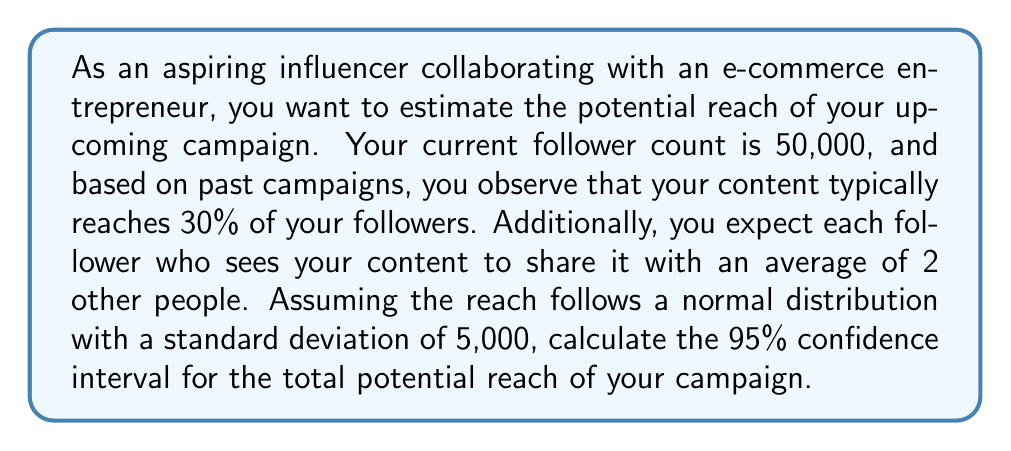Teach me how to tackle this problem. Let's approach this problem step-by-step:

1. Calculate the expected direct reach:
   $$ \text{Direct Reach} = 50,000 \times 0.30 = 15,000 \text{ followers} $$

2. Calculate the expected indirect reach:
   $$ \text{Indirect Reach} = 15,000 \times 2 = 30,000 \text{ people} $$

3. Calculate the total expected reach:
   $$ \text{Total Expected Reach} = 15,000 + 30,000 = 45,000 \text{ people} $$

4. For a 95% confidence interval, we need to find the z-score, which is 1.96 for a two-tailed test.

5. The formula for the confidence interval is:
   $$ CI = \bar{x} \pm z \frac{\sigma}{\sqrt{n}} $$
   Where:
   - $\bar{x}$ is the expected reach (45,000)
   - $z$ is the z-score (1.96)
   - $\sigma$ is the standard deviation (5,000)
   - $n$ is the sample size, which in this case is 1 as we're dealing with a single campaign

6. Plugging in the values:
   $$ CI = 45,000 \pm 1.96 \frac{5,000}{\sqrt{1}} $$
   $$ CI = 45,000 \pm 1.96 \times 5,000 $$
   $$ CI = 45,000 \pm 9,800 $$

7. Calculate the lower and upper bounds:
   Lower bound: $45,000 - 9,800 = 35,200$
   Upper bound: $45,000 + 9,800 = 54,800$

Therefore, the 95% confidence interval for the total potential reach of your campaign is (35,200, 54,800) people.
Answer: The 95% confidence interval for the total potential reach of the influencer campaign is (35,200, 54,800) people. 